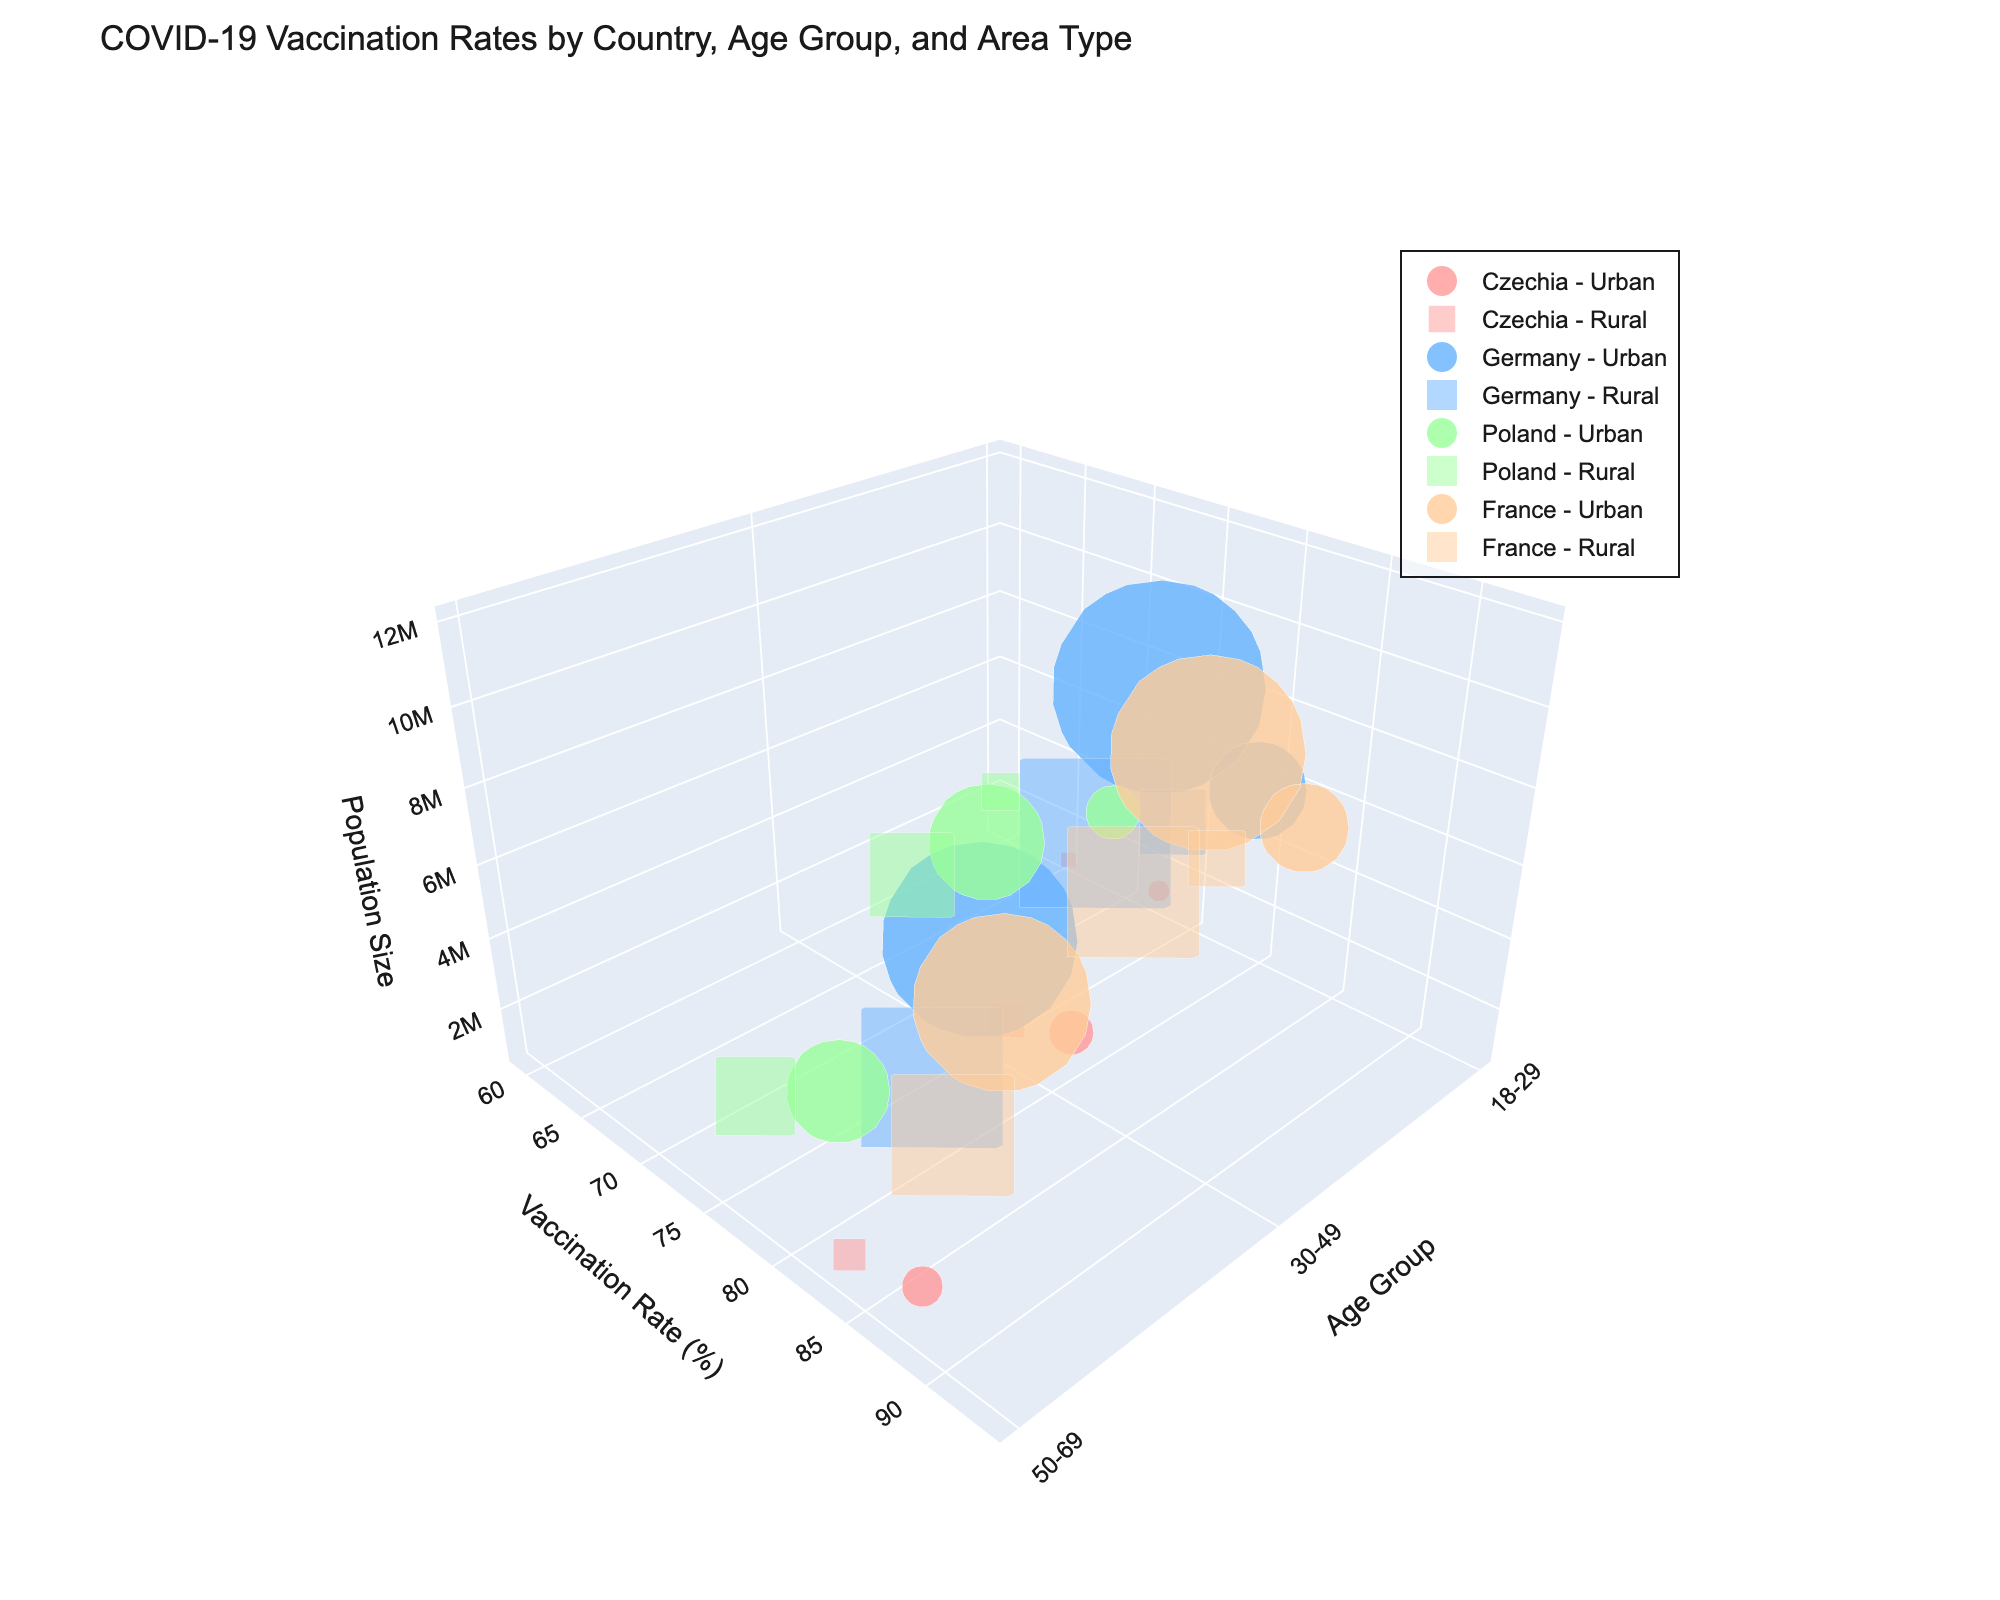What's the title of the figure? The title of the figure is usually the most prominent text at the top of the visualization. In this case, it states, "COVID-19 Vaccination Rates by Country, Age Group, and Area Type."
Answer: COVID-19 Vaccination Rates by Country, Age Group, and Area Type How many countries are represented in the figure? By examining the legend and identifying distinct markers for each country, we note that there are four countries included: Czechia, Germany, Poland, and France.
Answer: Four Which Age Group has the highest vaccination rate in urban areas of France? By analyzing the y-axis for "Vaccination Rate" and the x-axis for "Age Group" while focusing on the "France - Urban" markers, we see that the age group 50-69 has the highest vaccination rate.
Answer: 50-69 Compare the vaccination rates of urban and rural areas in Germany for the age group 30-49. Which area has a higher rate? Look at the markers for Germany within the age group 30-49, then compare the y-axis values (vaccination rates). The urban area marker is higher on the y-axis than the rural marker.
Answer: Urban What is the relationship between the population size and the size of the markers in the figure? The plot uses larger markers for larger population sizes and smaller markers for smaller populations, indicating that marker size is directly proportional to the population size.
Answer: Directly proportional What is the average vaccination rate for the age group 18-29 in urban areas across all countries? Find the urban vaccination rates for 18-29 across all countries (72.5, 78.9, 68.7, 82.1). Calculate the average: (72.5 + 78.9 + 68.7 + 82.1) / 4.
Answer: 75.55% Which country has the lowest rural vaccination rate in the age group 50-69? By looking at the markers for the age group 50-69 in rural areas, we identify the lowest y-axis value among these markers. Poland has the lowest rate at 78.2%.
Answer: Poland For Czechia, which has a higher vaccination rate for the age group 30-49, urban or rural areas? Compare the markers for Czechia in the age group 30-49; the urban area has a higher marker position on the y-axis compared to the rural.
Answer: Urban In Germany, do rural areas or urban areas have a larger population size in the age group 50-69? Compare the sizes of the markers for Germany in the age group 50-69; the rural areas have smaller sized markers, indicating a smaller population.
Answer: Urban How does the vaccination rate for rural areas in Poland's age group 18-29 compare with urban areas in France for the same age group? Compare the markers for rural Poland (age 18-29) and urban France (age 18-29). Poland has 59.4% and France has 82.1%. The vaccination rate for rural Poland is significantly lower.
Answer: Rural Poland is lower 